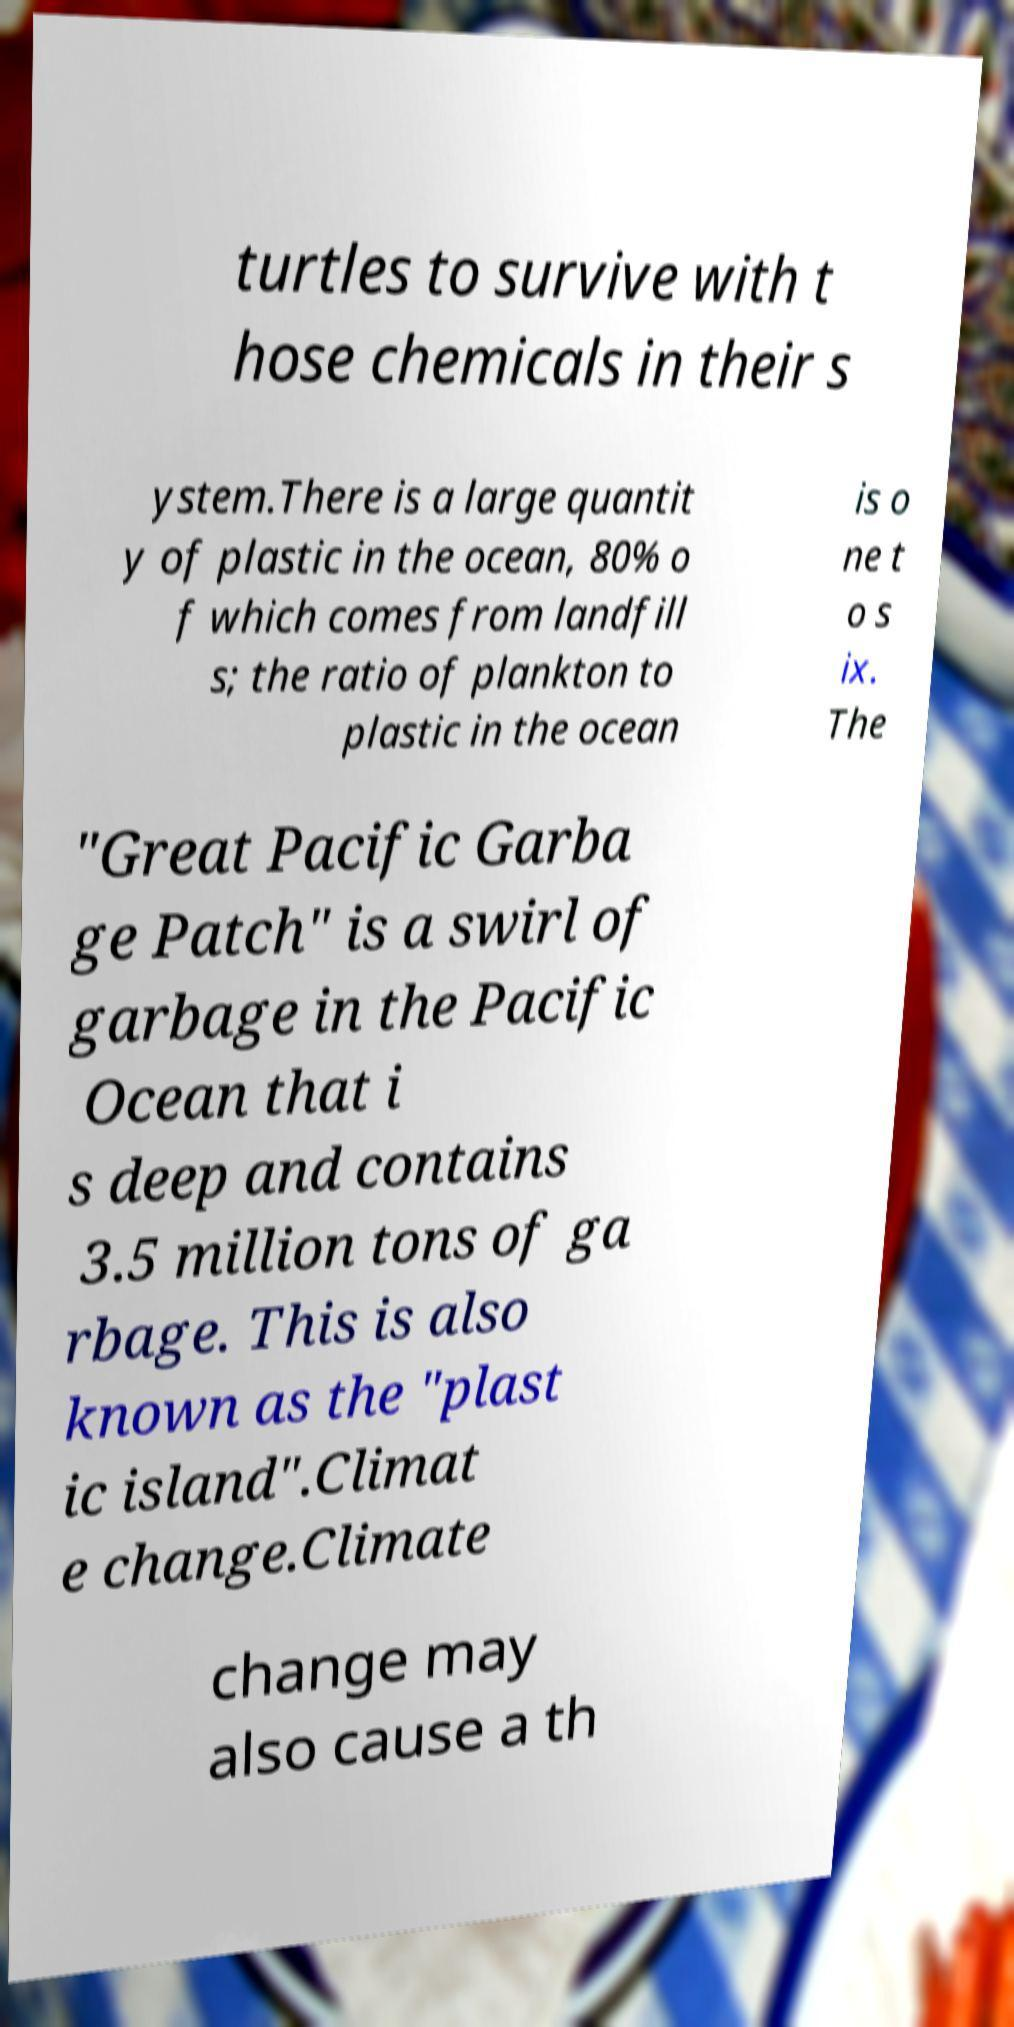There's text embedded in this image that I need extracted. Can you transcribe it verbatim? turtles to survive with t hose chemicals in their s ystem.There is a large quantit y of plastic in the ocean, 80% o f which comes from landfill s; the ratio of plankton to plastic in the ocean is o ne t o s ix. The "Great Pacific Garba ge Patch" is a swirl of garbage in the Pacific Ocean that i s deep and contains 3.5 million tons of ga rbage. This is also known as the "plast ic island".Climat e change.Climate change may also cause a th 